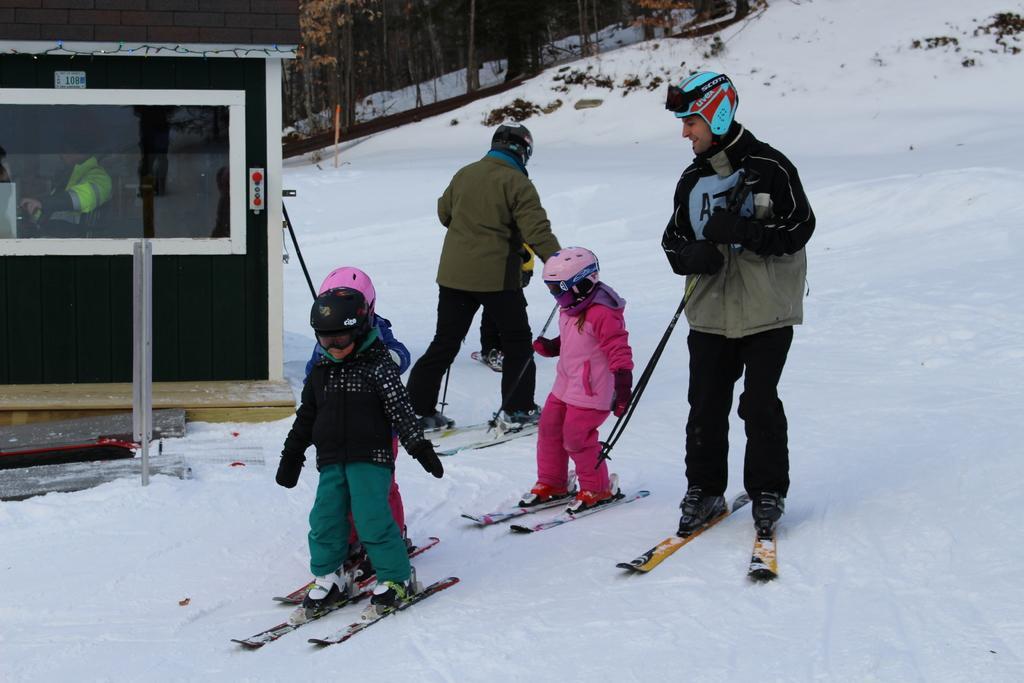Could you give a brief overview of what you see in this image? In this picture there are children and two men in the center of the image, they are skating and there are trees at the top side of the image, there is snow around the area of the image. 